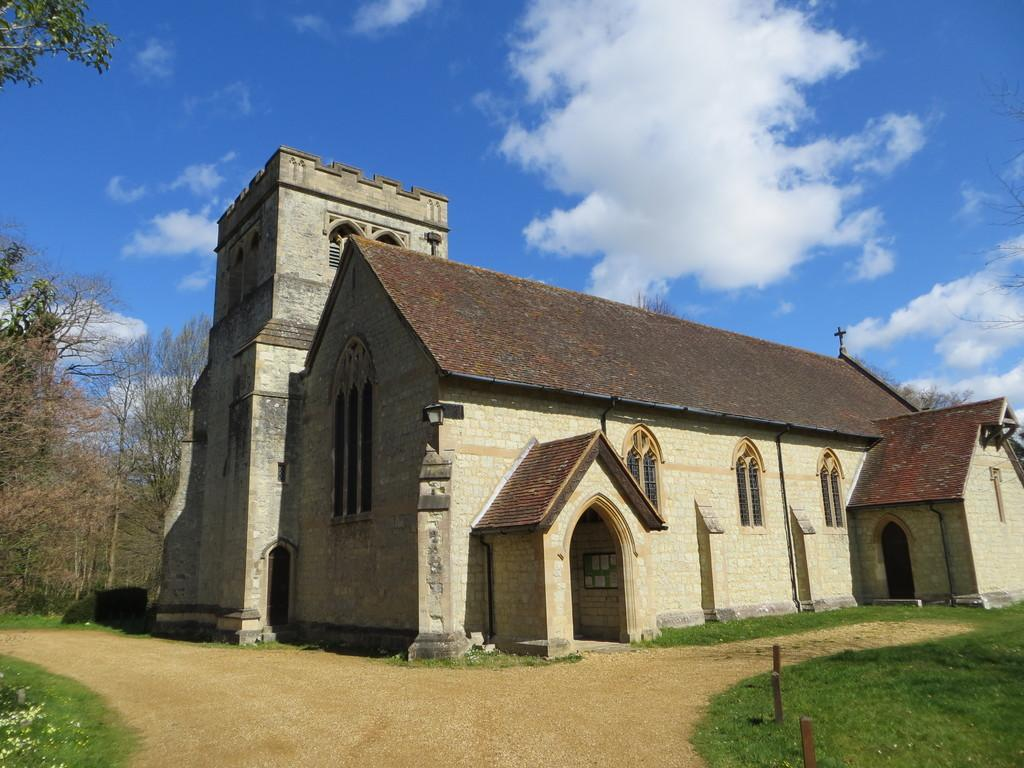What type of structure is present in the image? There is a building in the image. What other natural elements can be seen in the image? There are trees and grass visible in the image. How would you describe the sky in the image? The sky is blue and cloudy in the image. What date is marked on the calendar in the image? There is no calendar present in the image. Can you see a train passing by in the image? There is no train visible in the image. 